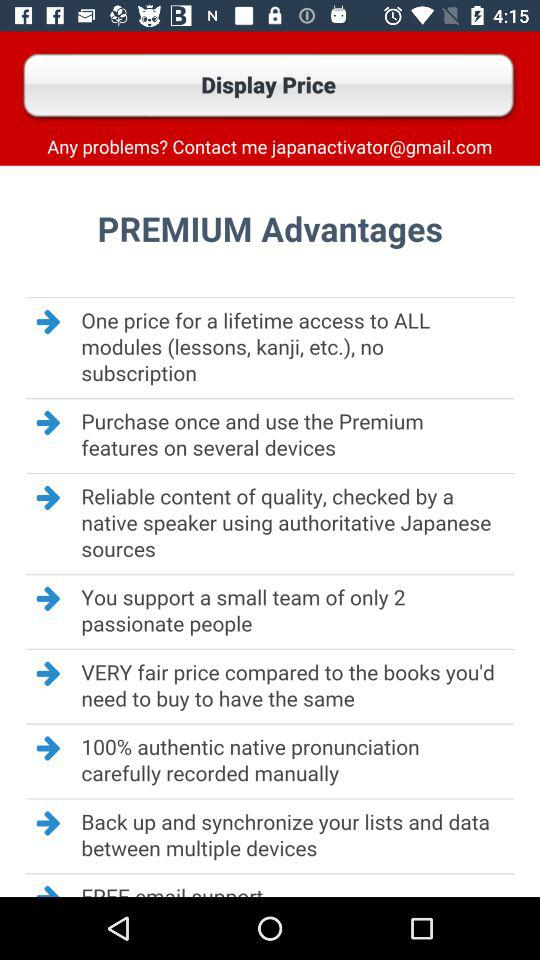How much does it cost for lifetime access to all modules?
When the provided information is insufficient, respond with <no answer>. <no answer> 